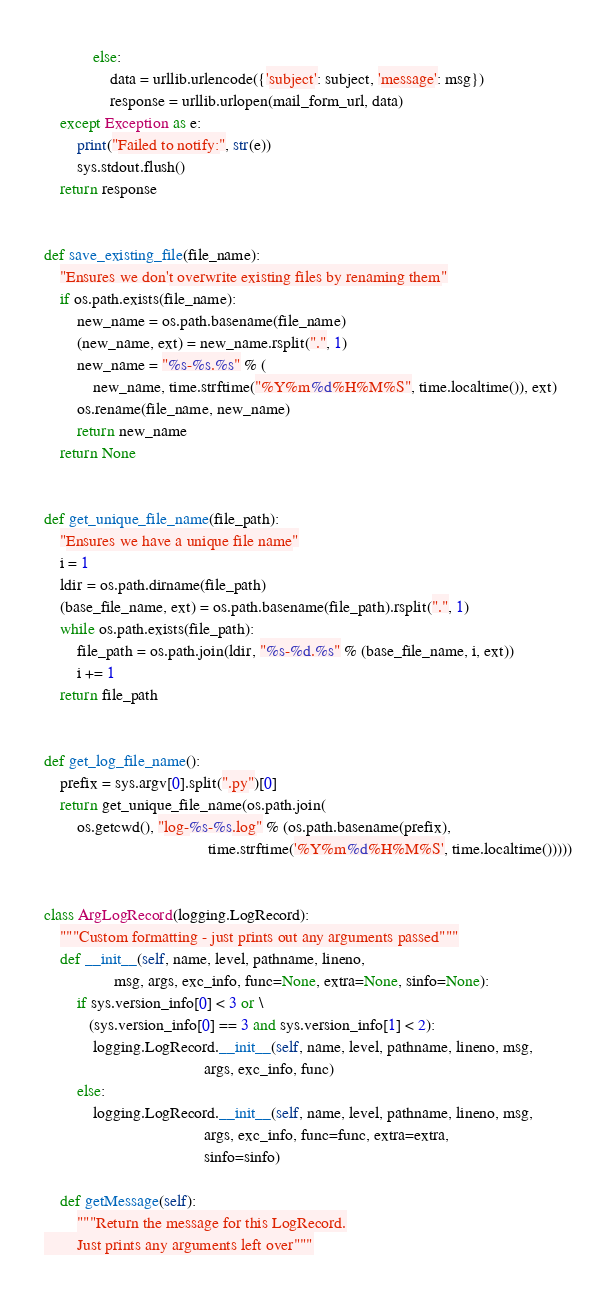Convert code to text. <code><loc_0><loc_0><loc_500><loc_500><_Python_>            else:
                data = urllib.urlencode({'subject': subject, 'message': msg})
                response = urllib.urlopen(mail_form_url, data)
    except Exception as e:
        print("Failed to notify:", str(e))
        sys.stdout.flush()
    return response


def save_existing_file(file_name):
    "Ensures we don't overwrite existing files by renaming them"
    if os.path.exists(file_name):
        new_name = os.path.basename(file_name)
        (new_name, ext) = new_name.rsplit(".", 1)
        new_name = "%s-%s.%s" % (
            new_name, time.strftime("%Y%m%d%H%M%S", time.localtime()), ext)
        os.rename(file_name, new_name)
        return new_name
    return None


def get_unique_file_name(file_path):
    "Ensures we have a unique file name"
    i = 1
    ldir = os.path.dirname(file_path)
    (base_file_name, ext) = os.path.basename(file_path).rsplit(".", 1)
    while os.path.exists(file_path):
        file_path = os.path.join(ldir, "%s-%d.%s" % (base_file_name, i, ext))
        i += 1
    return file_path


def get_log_file_name():
    prefix = sys.argv[0].split(".py")[0]
    return get_unique_file_name(os.path.join(
        os.getcwd(), "log-%s-%s.log" % (os.path.basename(prefix),
                                        time.strftime('%Y%m%d%H%M%S', time.localtime()))))


class ArgLogRecord(logging.LogRecord):
    """Custom formatting - just prints out any arguments passed"""
    def __init__(self, name, level, pathname, lineno,
                 msg, args, exc_info, func=None, extra=None, sinfo=None):
        if sys.version_info[0] < 3 or \
           (sys.version_info[0] == 3 and sys.version_info[1] < 2):
            logging.LogRecord.__init__(self, name, level, pathname, lineno, msg,
                                       args, exc_info, func)
        else:
            logging.LogRecord.__init__(self, name, level, pathname, lineno, msg,
                                       args, exc_info, func=func, extra=extra,
                                       sinfo=sinfo)

    def getMessage(self):
        """Return the message for this LogRecord.
        Just prints any arguments left over"""</code> 